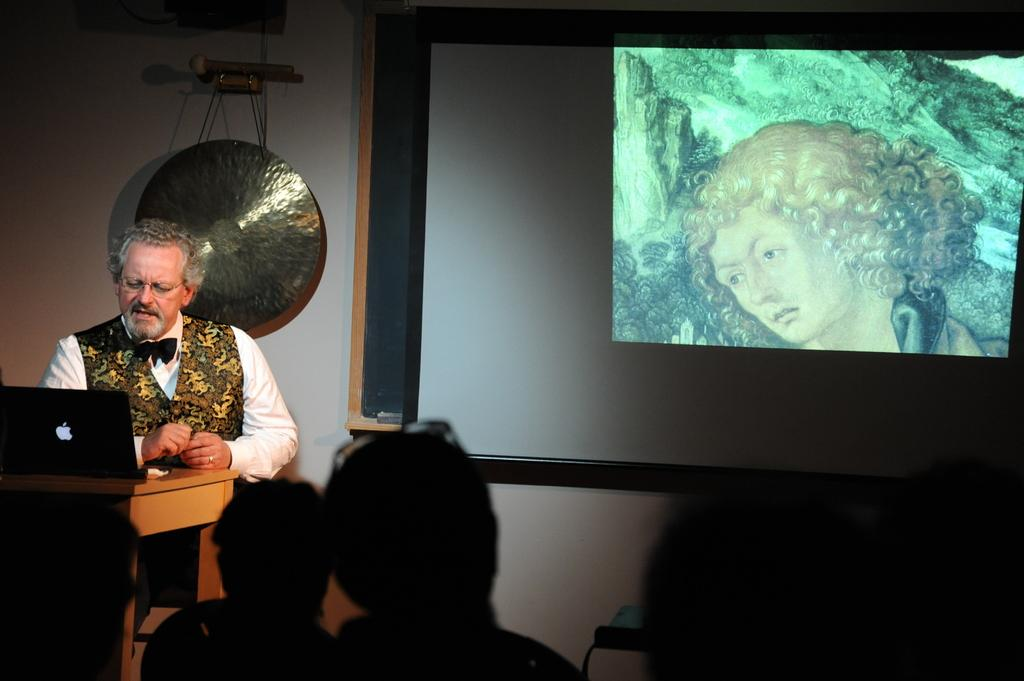Who is the main subject in the image? There is a man in the image. What is the man doing in the image? The man is sitting in front of a table. What object is on the table in the image? There is a laptop on the table. What can be seen behind the man in the image? There is a big screen with a painting behind the man. Are there any other people in the image besides the man? Yes, there are people in front of the big screen. What type of robin can be seen flying over the laptop in the image? There is no robin present in the image; it is a man sitting in front of a table with a laptop. Can you tell me how many airplanes are visible in the image? There are no airplanes visible in the image. 